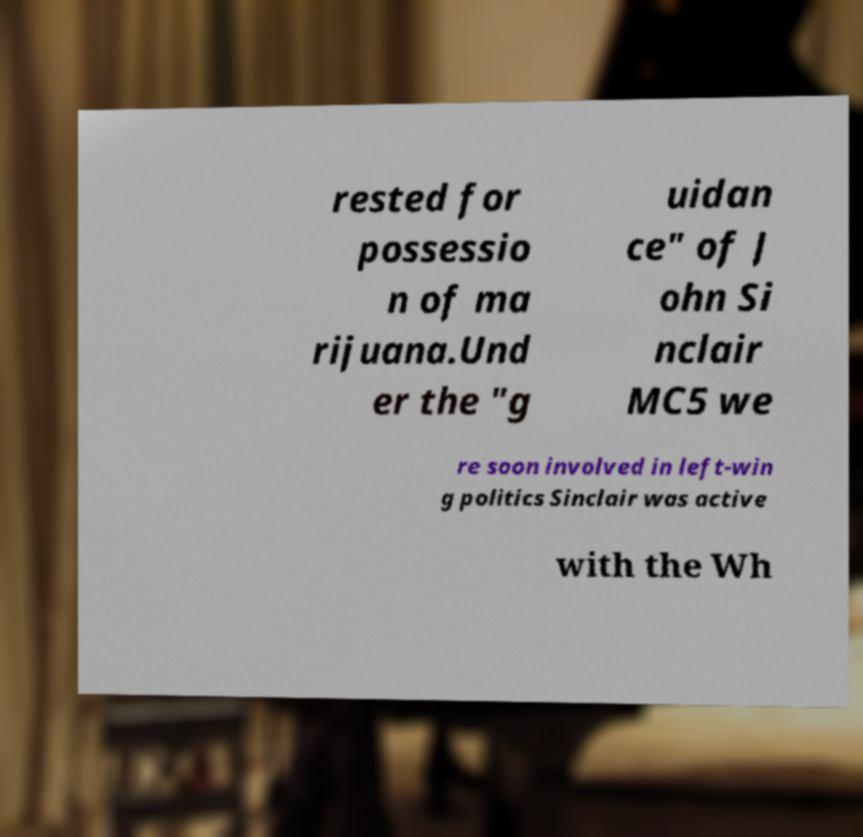Can you read and provide the text displayed in the image?This photo seems to have some interesting text. Can you extract and type it out for me? rested for possessio n of ma rijuana.Und er the "g uidan ce" of J ohn Si nclair MC5 we re soon involved in left-win g politics Sinclair was active with the Wh 